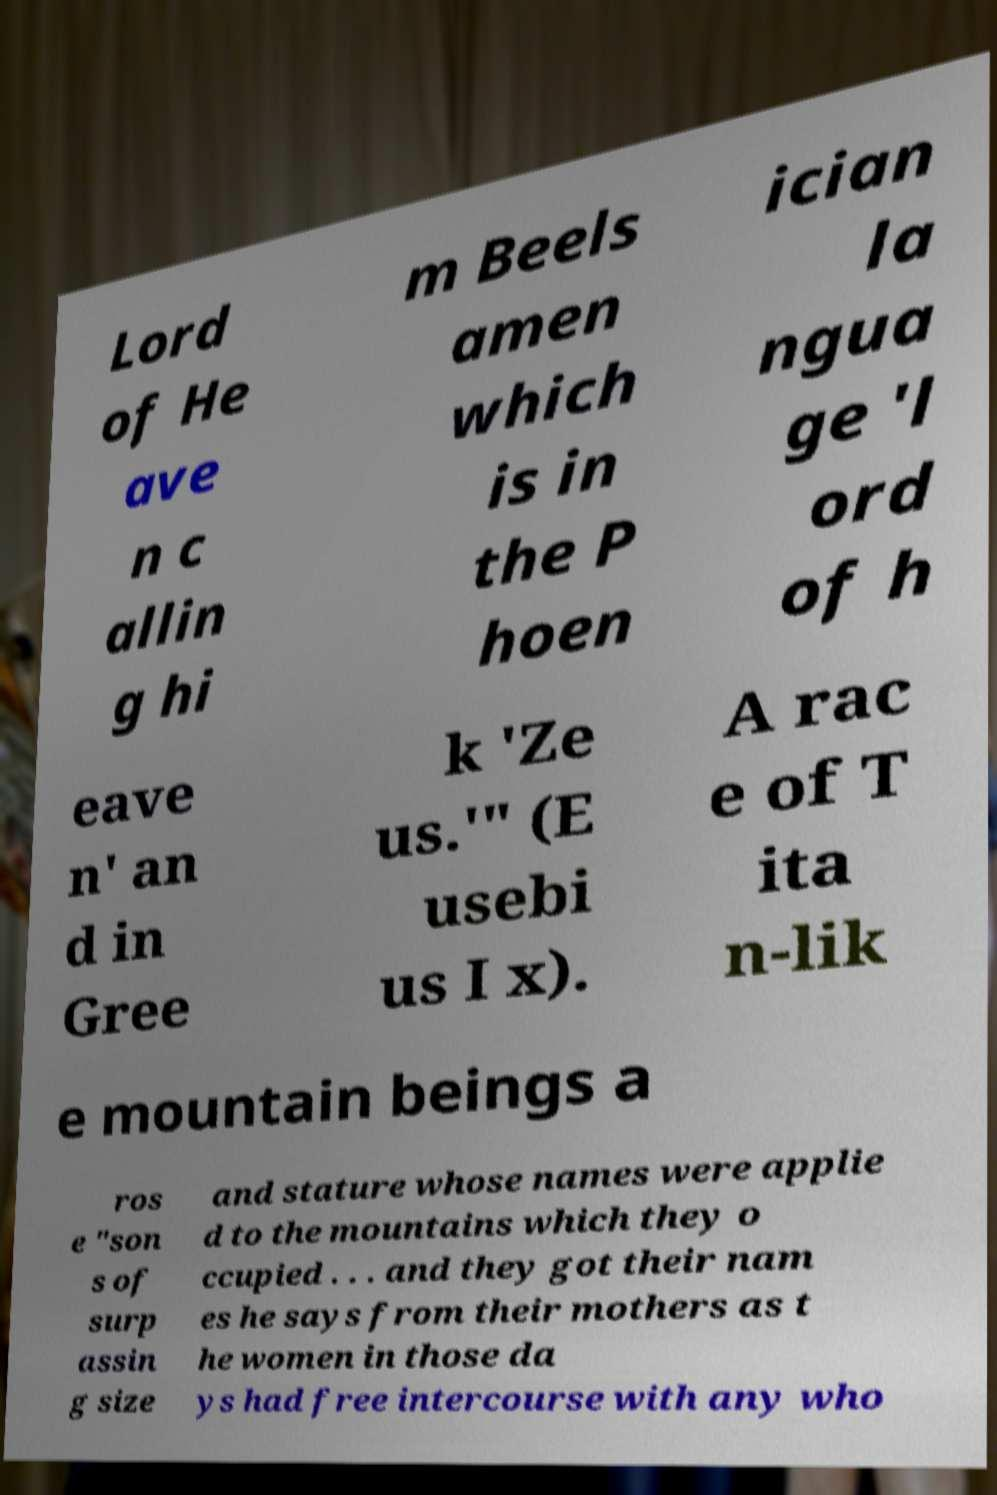Can you read and provide the text displayed in the image?This photo seems to have some interesting text. Can you extract and type it out for me? Lord of He ave n c allin g hi m Beels amen which is in the P hoen ician la ngua ge 'l ord of h eave n' an d in Gree k 'Ze us.'" (E usebi us I x). A rac e of T ita n-lik e mountain beings a ros e "son s of surp assin g size and stature whose names were applie d to the mountains which they o ccupied . . . and they got their nam es he says from their mothers as t he women in those da ys had free intercourse with any who 